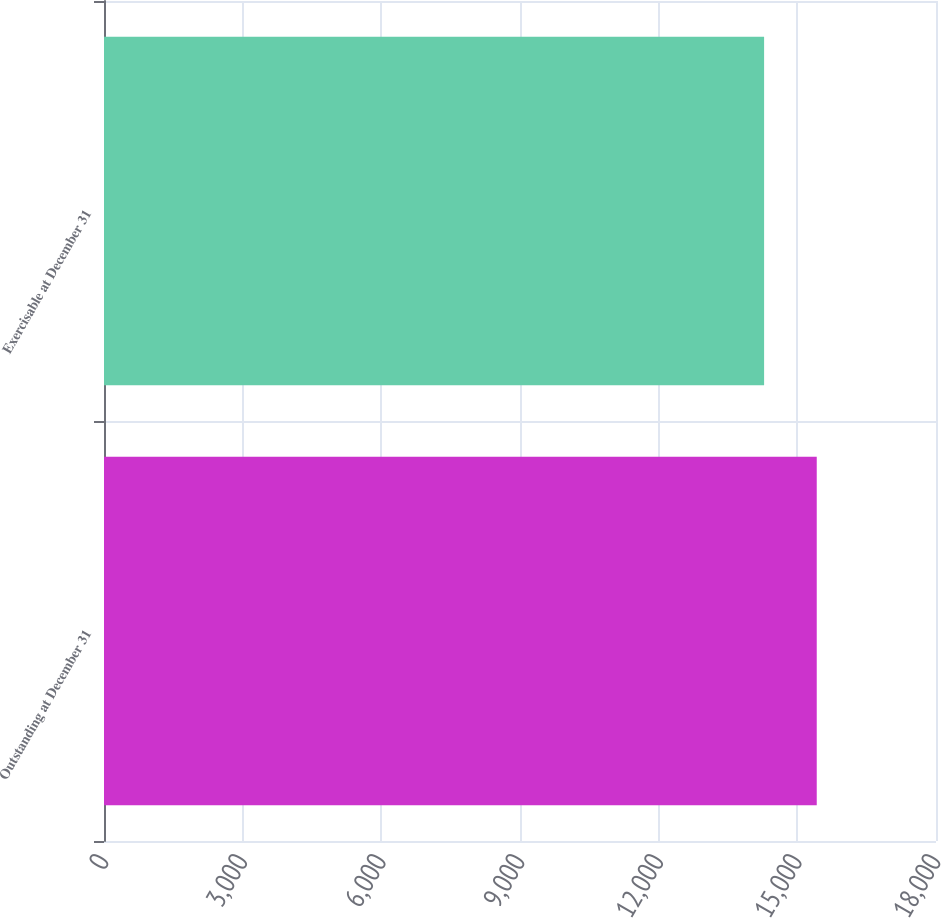<chart> <loc_0><loc_0><loc_500><loc_500><bar_chart><fcel>Outstanding at December 31<fcel>Exercisable at December 31<nl><fcel>15420<fcel>14281<nl></chart> 